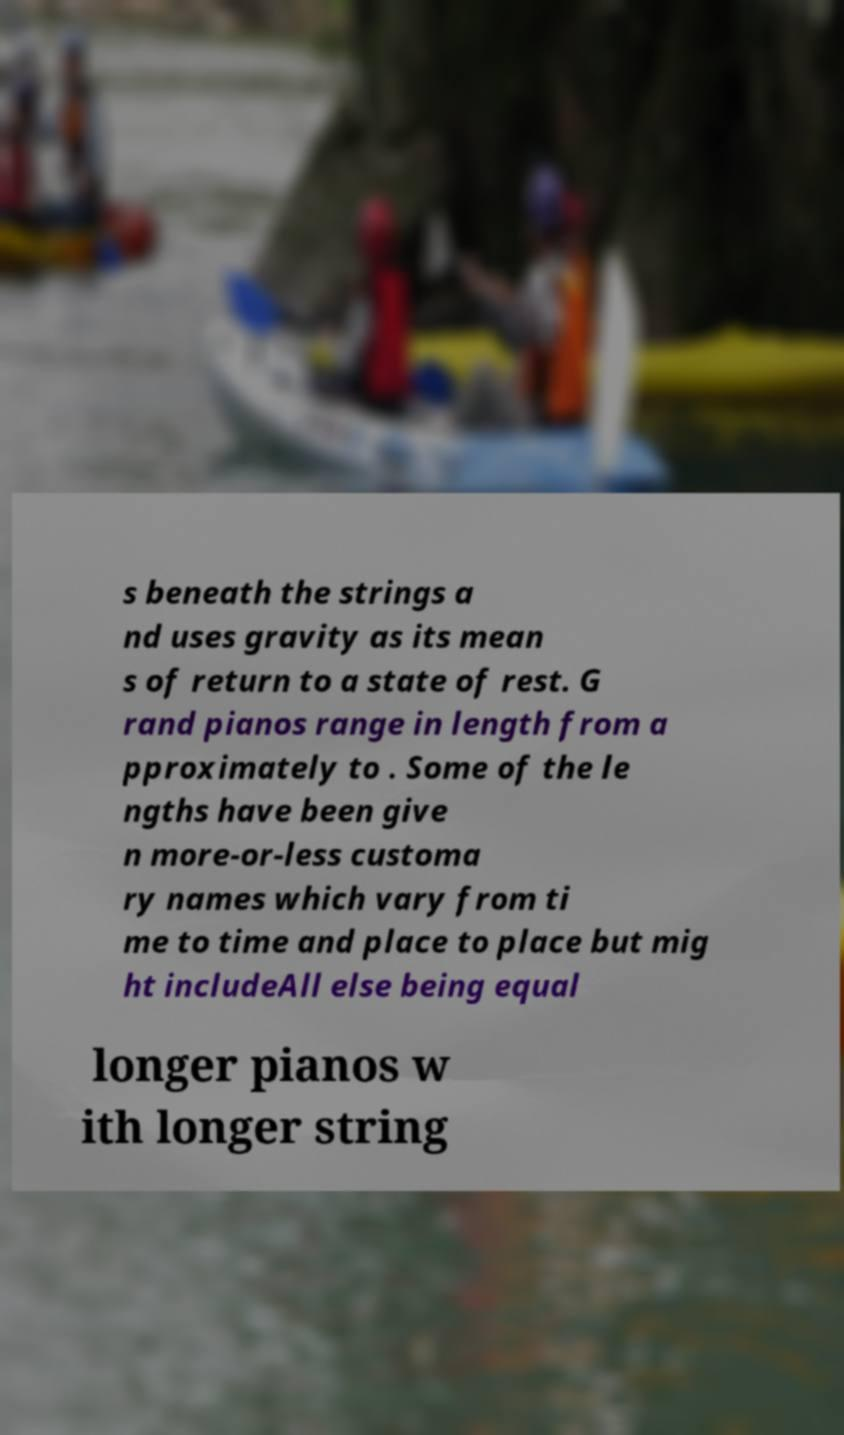Please read and relay the text visible in this image. What does it say? s beneath the strings a nd uses gravity as its mean s of return to a state of rest. G rand pianos range in length from a pproximately to . Some of the le ngths have been give n more-or-less customa ry names which vary from ti me to time and place to place but mig ht includeAll else being equal longer pianos w ith longer string 